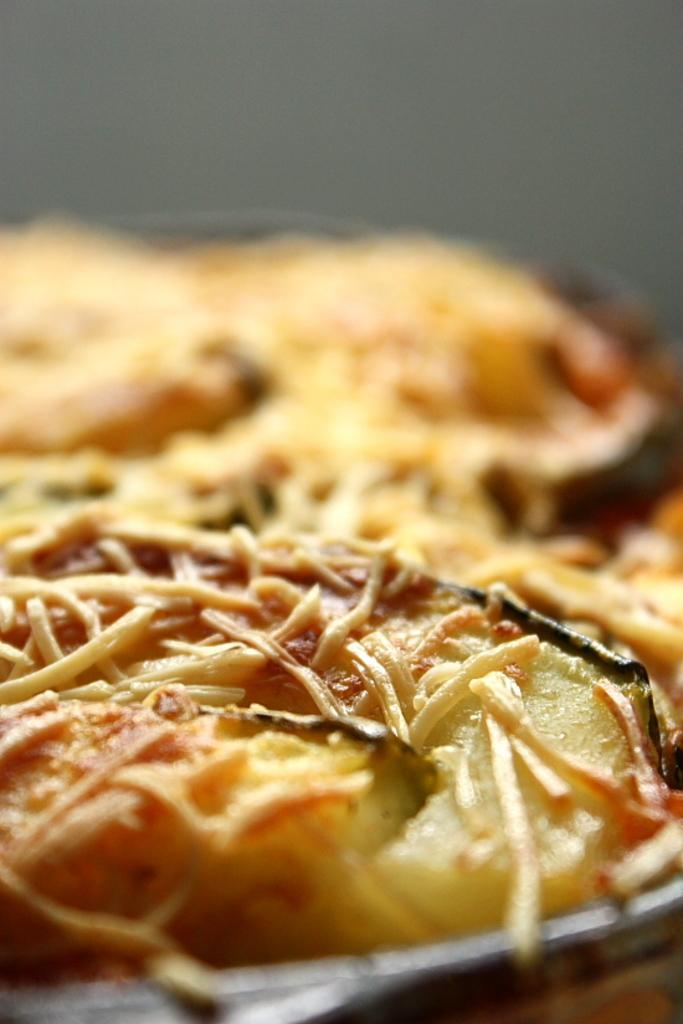What type of food is on the plate in the image? There is a pizza on a plate in the image. Where is the plate with the pizza located? The plate is placed on a table. What can be seen at the top of the image? There is a wall visible at the top of the image. What type of plantation can be seen growing on the pizza in the image? There is no plantation present on the pizza in the image; it is a pizza with no visible toppings other than cheese and sauce. 